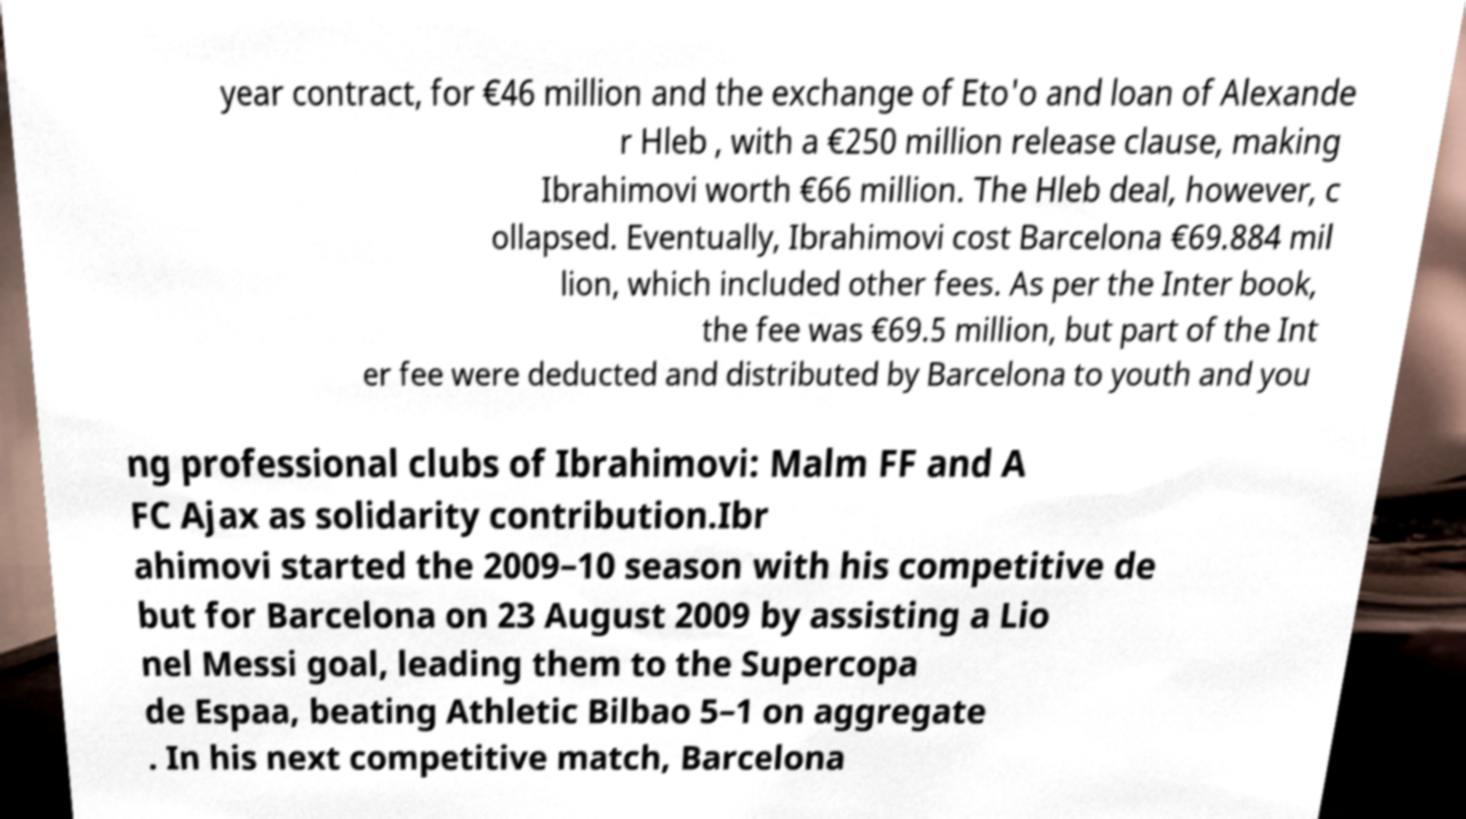Can you accurately transcribe the text from the provided image for me? year contract, for €46 million and the exchange of Eto'o and loan of Alexande r Hleb , with a €250 million release clause, making Ibrahimovi worth €66 million. The Hleb deal, however, c ollapsed. Eventually, Ibrahimovi cost Barcelona €69.884 mil lion, which included other fees. As per the Inter book, the fee was €69.5 million, but part of the Int er fee were deducted and distributed by Barcelona to youth and you ng professional clubs of Ibrahimovi: Malm FF and A FC Ajax as solidarity contribution.Ibr ahimovi started the 2009–10 season with his competitive de but for Barcelona on 23 August 2009 by assisting a Lio nel Messi goal, leading them to the Supercopa de Espaa, beating Athletic Bilbao 5–1 on aggregate . In his next competitive match, Barcelona 